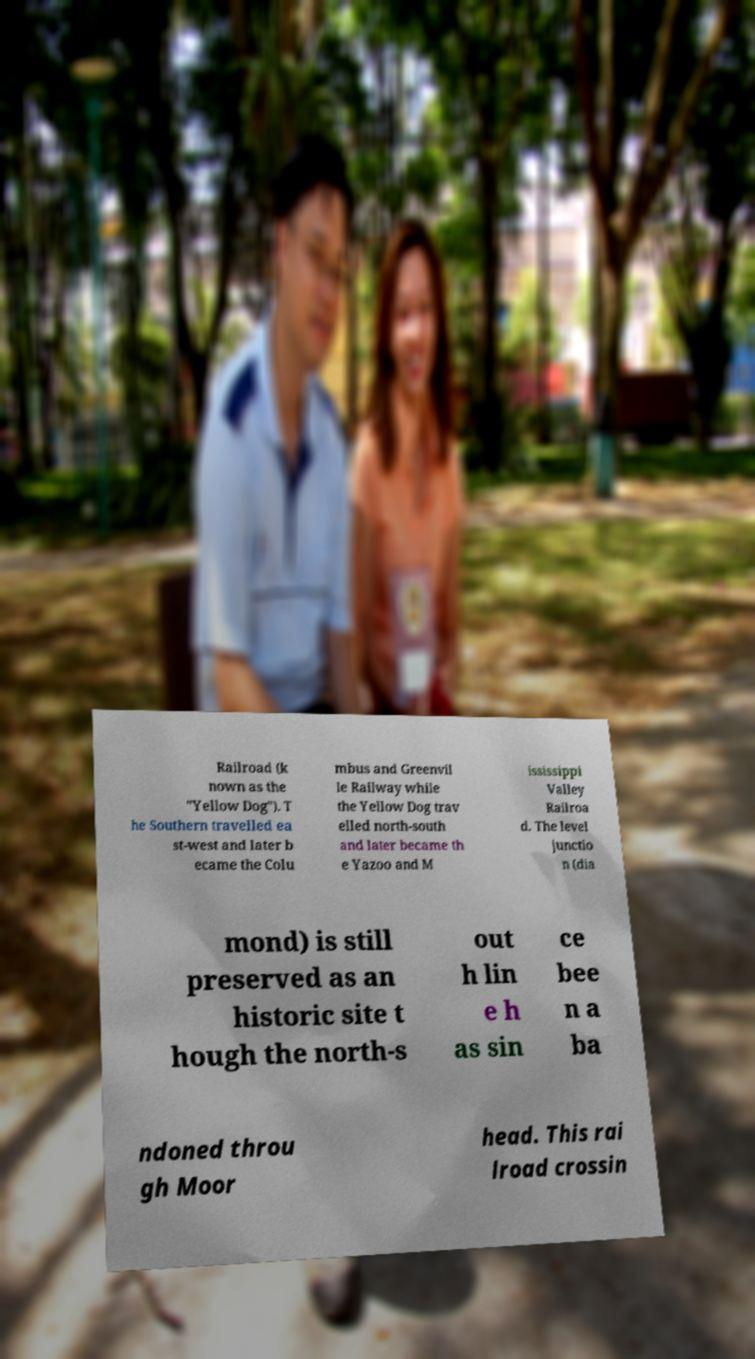Please identify and transcribe the text found in this image. Railroad (k nown as the "Yellow Dog"). T he Southern travelled ea st-west and later b ecame the Colu mbus and Greenvil le Railway while the Yellow Dog trav elled north-south and later became th e Yazoo and M ississippi Valley Railroa d. The level junctio n (dia mond) is still preserved as an historic site t hough the north-s out h lin e h as sin ce bee n a ba ndoned throu gh Moor head. This rai lroad crossin 